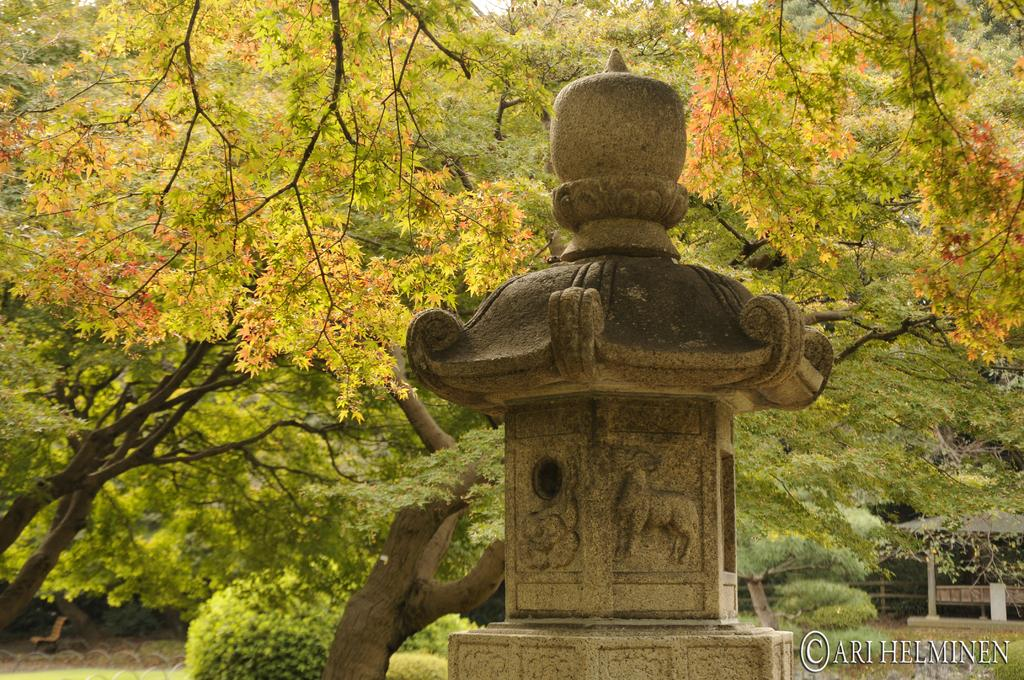What is the main subject in the middle of the image? There is a stone pillar in the middle of the image. What can be seen on the stone pillar? There are sculptures on the pillar. What type of natural elements are visible in the background of the image? There are trees in the background of the image. How many items are on the list in the image? There is no list present in the image. Can you see a bike in the image? There is no bike present in the image. 